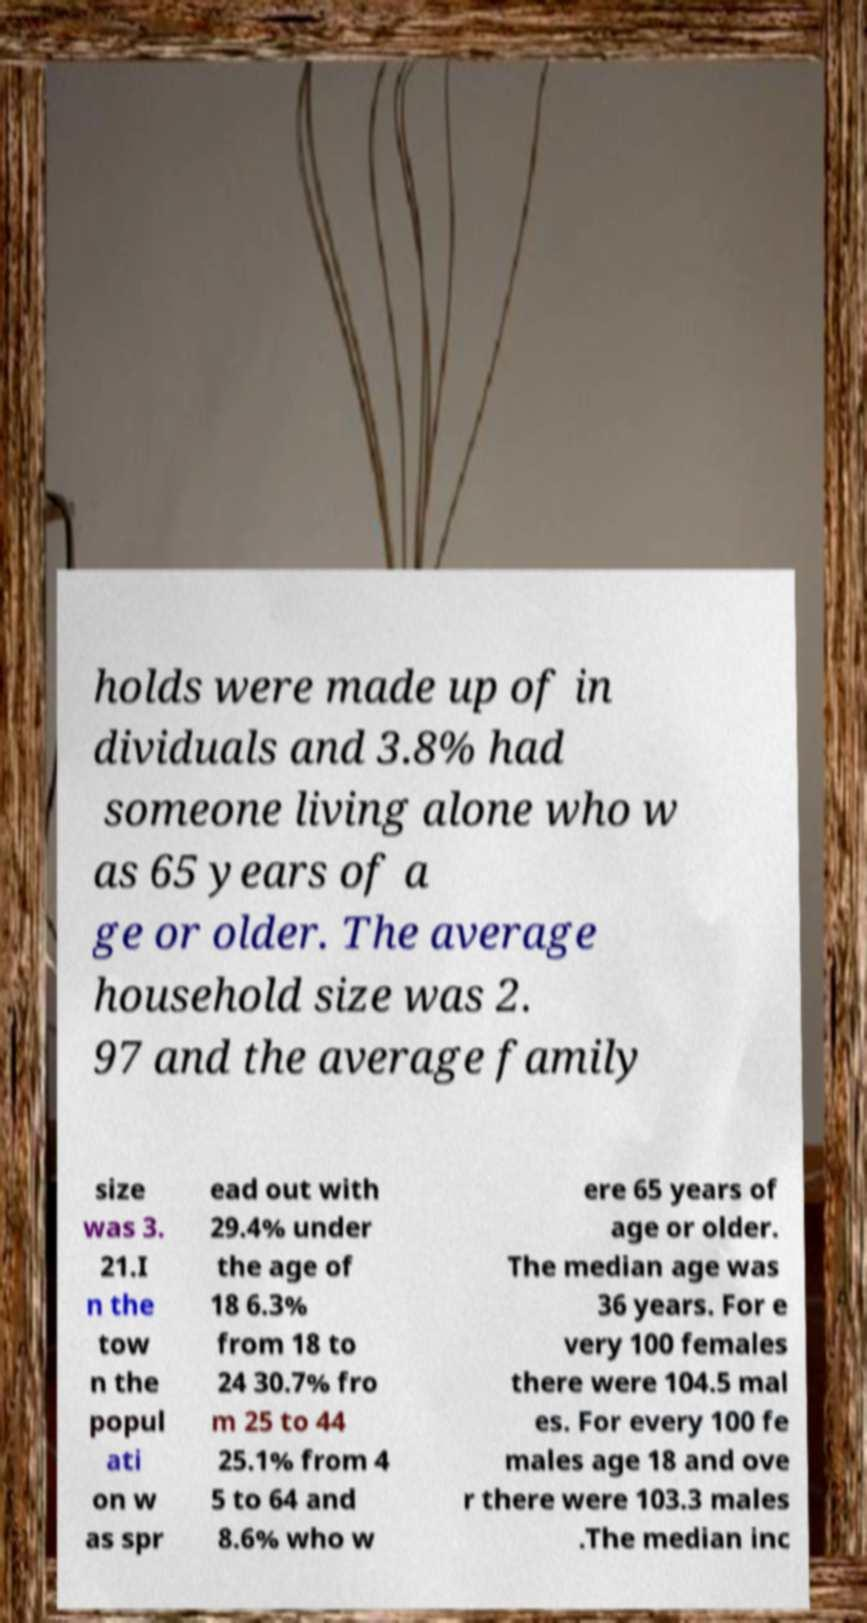Please identify and transcribe the text found in this image. holds were made up of in dividuals and 3.8% had someone living alone who w as 65 years of a ge or older. The average household size was 2. 97 and the average family size was 3. 21.I n the tow n the popul ati on w as spr ead out with 29.4% under the age of 18 6.3% from 18 to 24 30.7% fro m 25 to 44 25.1% from 4 5 to 64 and 8.6% who w ere 65 years of age or older. The median age was 36 years. For e very 100 females there were 104.5 mal es. For every 100 fe males age 18 and ove r there were 103.3 males .The median inc 